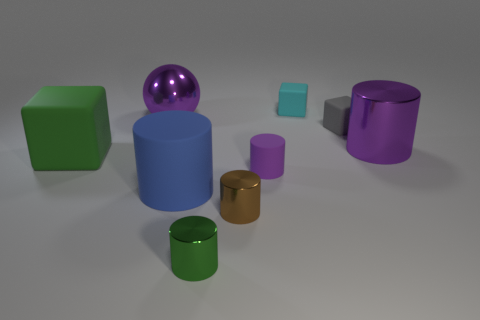Subtract 1 blocks. How many blocks are left? 2 Subtract all green blocks. How many blocks are left? 2 Subtract all green spheres. How many purple cylinders are left? 2 Subtract all blue cylinders. How many cylinders are left? 4 Subtract all gray cylinders. Subtract all yellow spheres. How many cylinders are left? 5 Subtract all balls. How many objects are left? 8 Subtract all big blue matte blocks. Subtract all blue cylinders. How many objects are left? 8 Add 2 big rubber objects. How many big rubber objects are left? 4 Add 9 small red metal spheres. How many small red metal spheres exist? 9 Subtract 0 blue blocks. How many objects are left? 9 